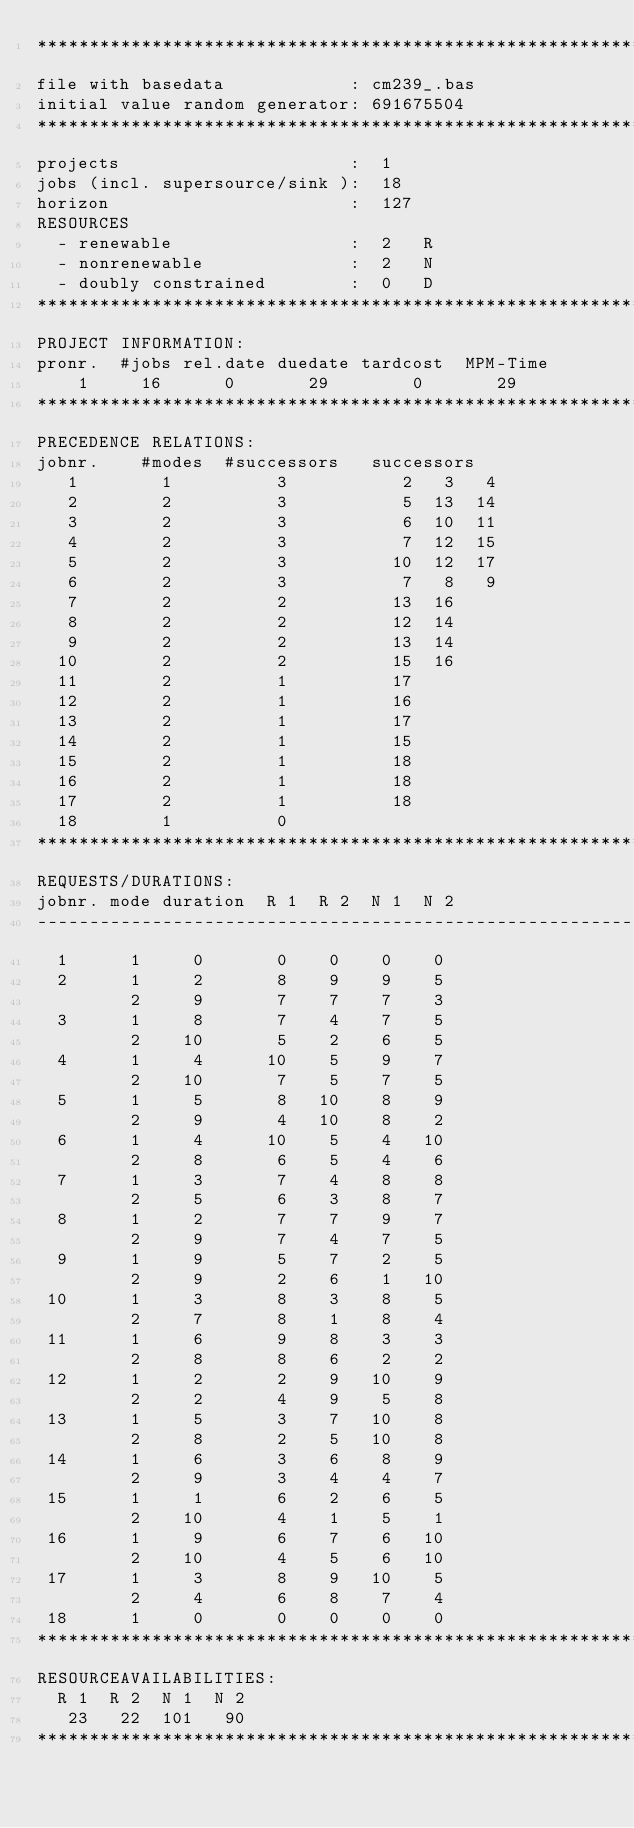<code> <loc_0><loc_0><loc_500><loc_500><_ObjectiveC_>************************************************************************
file with basedata            : cm239_.bas
initial value random generator: 691675504
************************************************************************
projects                      :  1
jobs (incl. supersource/sink ):  18
horizon                       :  127
RESOURCES
  - renewable                 :  2   R
  - nonrenewable              :  2   N
  - doubly constrained        :  0   D
************************************************************************
PROJECT INFORMATION:
pronr.  #jobs rel.date duedate tardcost  MPM-Time
    1     16      0       29        0       29
************************************************************************
PRECEDENCE RELATIONS:
jobnr.    #modes  #successors   successors
   1        1          3           2   3   4
   2        2          3           5  13  14
   3        2          3           6  10  11
   4        2          3           7  12  15
   5        2          3          10  12  17
   6        2          3           7   8   9
   7        2          2          13  16
   8        2          2          12  14
   9        2          2          13  14
  10        2          2          15  16
  11        2          1          17
  12        2          1          16
  13        2          1          17
  14        2          1          15
  15        2          1          18
  16        2          1          18
  17        2          1          18
  18        1          0        
************************************************************************
REQUESTS/DURATIONS:
jobnr. mode duration  R 1  R 2  N 1  N 2
------------------------------------------------------------------------
  1      1     0       0    0    0    0
  2      1     2       8    9    9    5
         2     9       7    7    7    3
  3      1     8       7    4    7    5
         2    10       5    2    6    5
  4      1     4      10    5    9    7
         2    10       7    5    7    5
  5      1     5       8   10    8    9
         2     9       4   10    8    2
  6      1     4      10    5    4   10
         2     8       6    5    4    6
  7      1     3       7    4    8    8
         2     5       6    3    8    7
  8      1     2       7    7    9    7
         2     9       7    4    7    5
  9      1     9       5    7    2    5
         2     9       2    6    1   10
 10      1     3       8    3    8    5
         2     7       8    1    8    4
 11      1     6       9    8    3    3
         2     8       8    6    2    2
 12      1     2       2    9   10    9
         2     2       4    9    5    8
 13      1     5       3    7   10    8
         2     8       2    5   10    8
 14      1     6       3    6    8    9
         2     9       3    4    4    7
 15      1     1       6    2    6    5
         2    10       4    1    5    1
 16      1     9       6    7    6   10
         2    10       4    5    6   10
 17      1     3       8    9   10    5
         2     4       6    8    7    4
 18      1     0       0    0    0    0
************************************************************************
RESOURCEAVAILABILITIES:
  R 1  R 2  N 1  N 2
   23   22  101   90
************************************************************************
</code> 